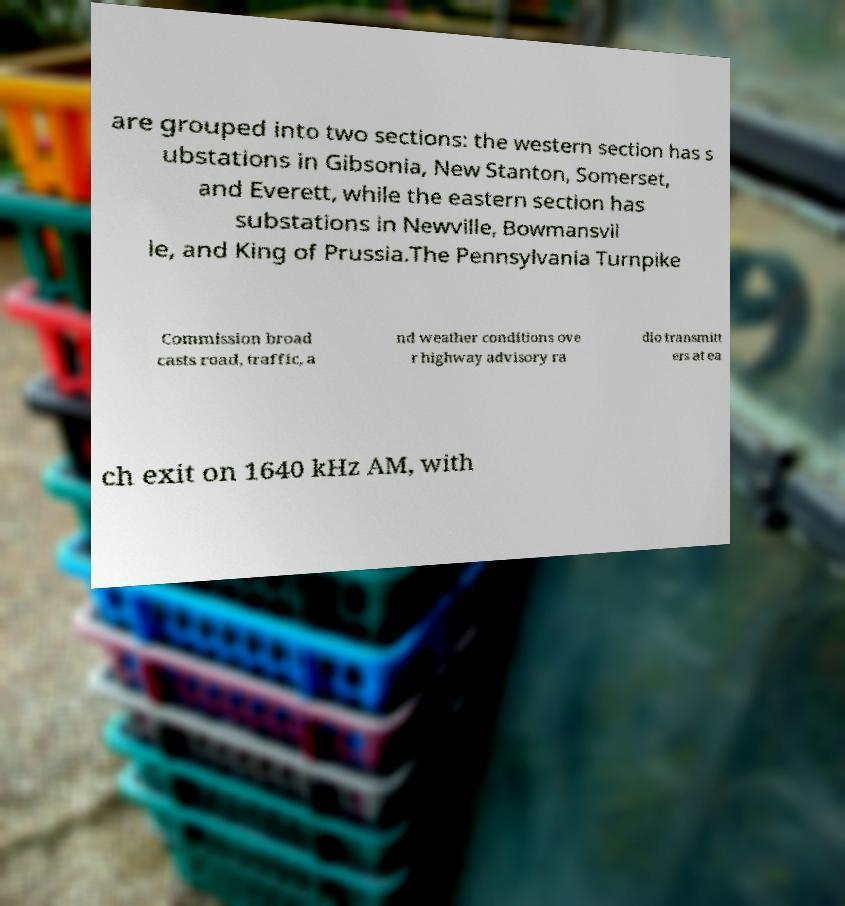Please identify and transcribe the text found in this image. are grouped into two sections: the western section has s ubstations in Gibsonia, New Stanton, Somerset, and Everett, while the eastern section has substations in Newville, Bowmansvil le, and King of Prussia.The Pennsylvania Turnpike Commission broad casts road, traffic, a nd weather conditions ove r highway advisory ra dio transmitt ers at ea ch exit on 1640 kHz AM, with 